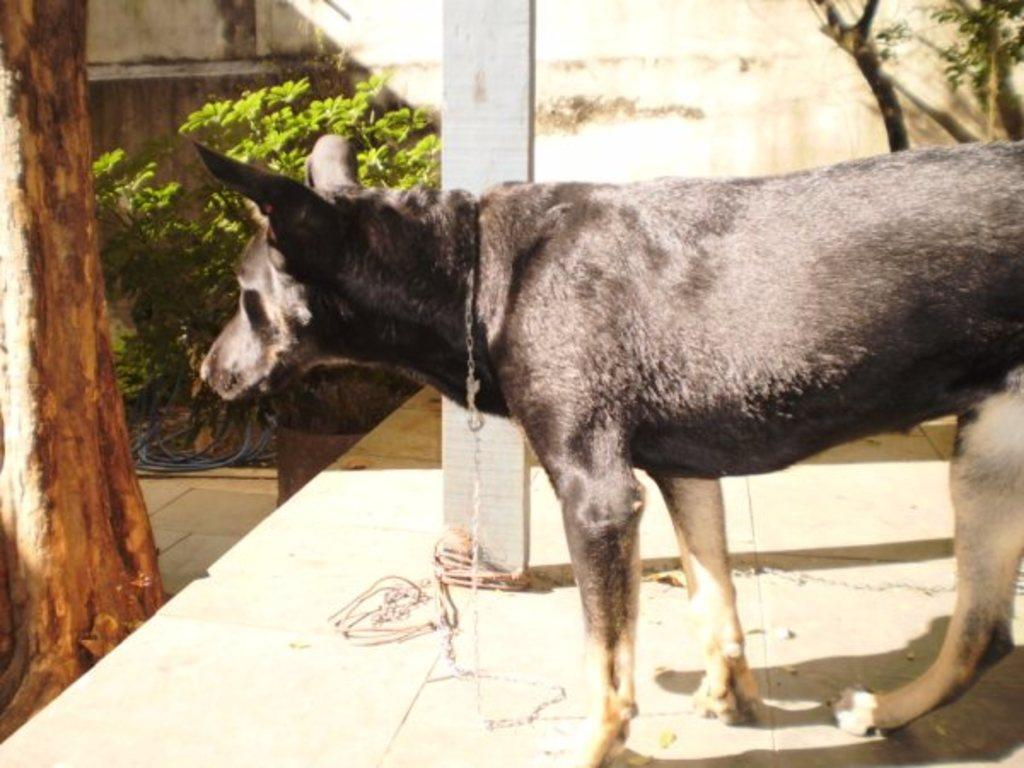What type of animal is in the image? There is a black dog in the image. Where is the dog located in relation to other objects? The dog is standing near a pole. What celestial bodies are visible in the image? There are planets visible in the image. Where are the planets situated in the image? The planets are near a wall. What type of vegetation is on the left side of the image? There is a tree on the left side of the image. Can you describe the airplane that is smashing into the tree in the image? There is no airplane present in the image, nor is there any indication of a collision or smashing into the tree. 